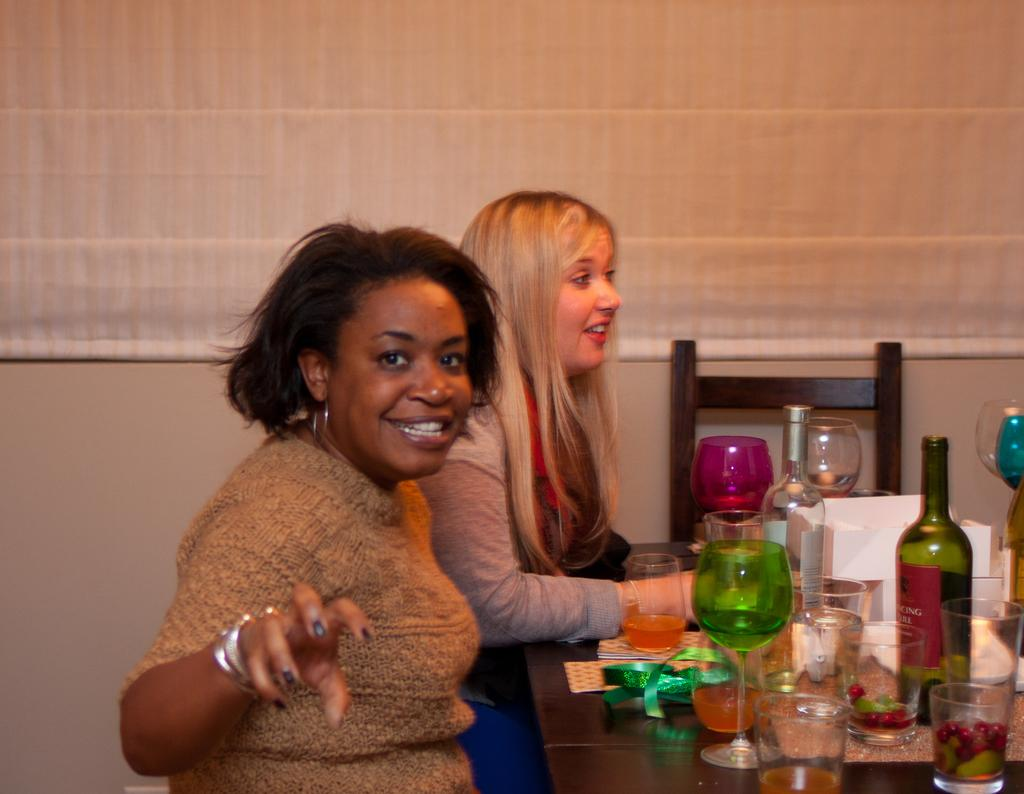What is the woman doing in the image? The woman is sitting on a chair in the image. What is located near the woman? There is a table in the image. What items are on the table? There is a wine bottle and wine glasses on the table. What type of pig is visible in the image? There is no pig present in the image. How many balloons are tied to the wine glasses in the image? There are no balloons present in the image. 